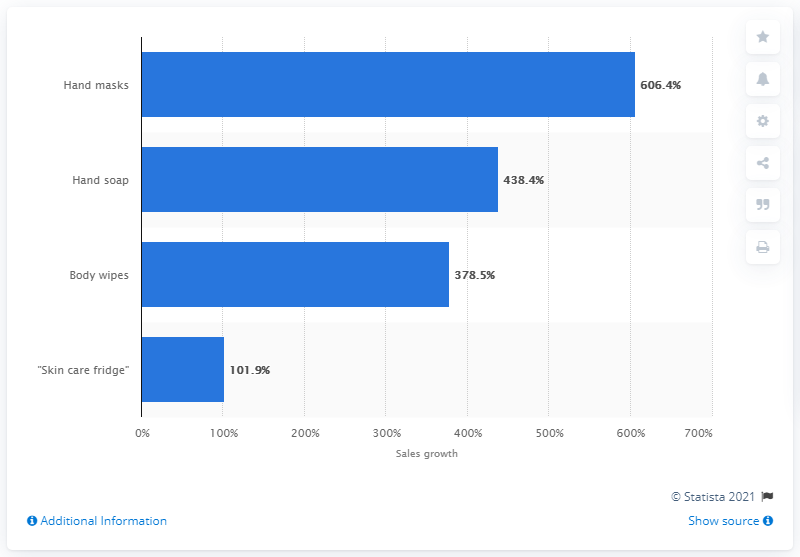Draw attention to some important aspects in this diagram. According to data collected from February to March 2020, sales of hand masks increased by 606.4% compared to the previous quarter. 